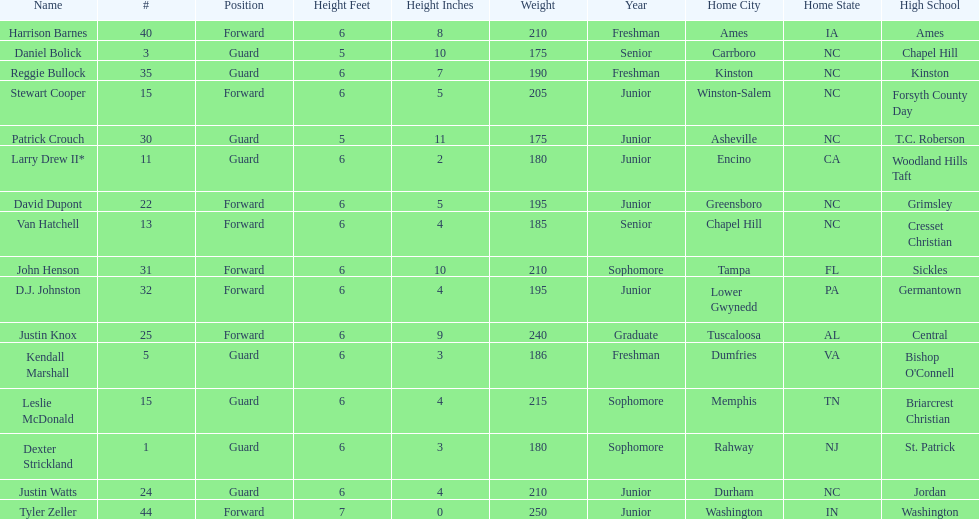How many players were taller than van hatchell? 7. Would you mind parsing the complete table? {'header': ['Name', '#', 'Position', 'Height Feet', 'Height Inches', 'Weight', 'Year', 'Home City', 'Home State', 'High School'], 'rows': [['Harrison Barnes', '40', 'Forward', '6', '8', '210', 'Freshman', 'Ames', 'IA', 'Ames'], ['Daniel Bolick', '3', 'Guard', '5', '10', '175', 'Senior', 'Carrboro', 'NC', 'Chapel Hill'], ['Reggie Bullock', '35', 'Guard', '6', '7', '190', 'Freshman', 'Kinston', 'NC', 'Kinston'], ['Stewart Cooper', '15', 'Forward', '6', '5', '205', 'Junior', 'Winston-Salem', 'NC', 'Forsyth County Day'], ['Patrick Crouch', '30', 'Guard', '5', '11', '175', 'Junior', 'Asheville', 'NC', 'T.C. Roberson'], ['Larry Drew II*', '11', 'Guard', '6', '2', '180', 'Junior', 'Encino', 'CA', 'Woodland Hills Taft'], ['David Dupont', '22', 'Forward', '6', '5', '195', 'Junior', 'Greensboro', 'NC', 'Grimsley'], ['Van Hatchell', '13', 'Forward', '6', '4', '185', 'Senior', 'Chapel Hill', 'NC', 'Cresset Christian'], ['John Henson', '31', 'Forward', '6', '10', '210', 'Sophomore', 'Tampa', 'FL', 'Sickles'], ['D.J. Johnston', '32', 'Forward', '6', '4', '195', 'Junior', 'Lower Gwynedd', 'PA', 'Germantown'], ['Justin Knox', '25', 'Forward', '6', '9', '240', 'Graduate', 'Tuscaloosa', 'AL', 'Central'], ['Kendall Marshall', '5', 'Guard', '6', '3', '186', 'Freshman', 'Dumfries', 'VA', "Bishop O'Connell"], ['Leslie McDonald', '15', 'Guard', '6', '4', '215', 'Sophomore', 'Memphis', 'TN', 'Briarcrest Christian'], ['Dexter Strickland', '1', 'Guard', '6', '3', '180', 'Sophomore', 'Rahway', 'NJ', 'St. Patrick'], ['Justin Watts', '24', 'Guard', '6', '4', '210', 'Junior', 'Durham', 'NC', 'Jordan'], ['Tyler Zeller', '44', 'Forward', '7', '0', '250', 'Junior', 'Washington', 'IN', 'Washington']]} 